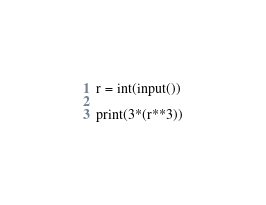Convert code to text. <code><loc_0><loc_0><loc_500><loc_500><_Python_>r = int(input())

print(3*(r**3))
</code> 